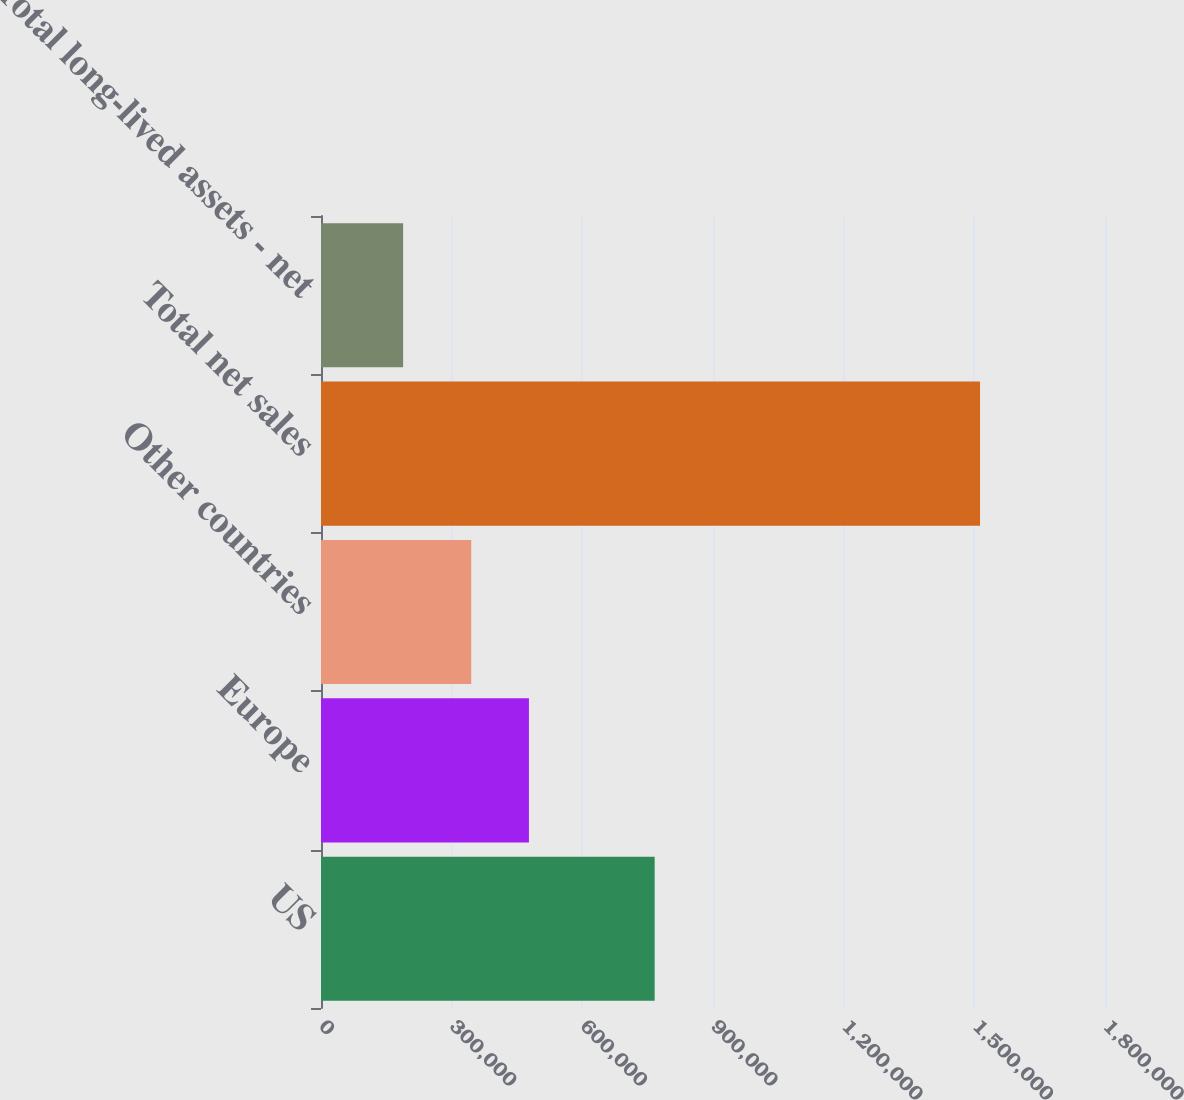Convert chart to OTSL. <chart><loc_0><loc_0><loc_500><loc_500><bar_chart><fcel>US<fcel>Europe<fcel>Other countries<fcel>Total net sales<fcel>Total long-lived assets - net<nl><fcel>766067<fcel>477401<fcel>344950<fcel>1.51307e+06<fcel>188562<nl></chart> 